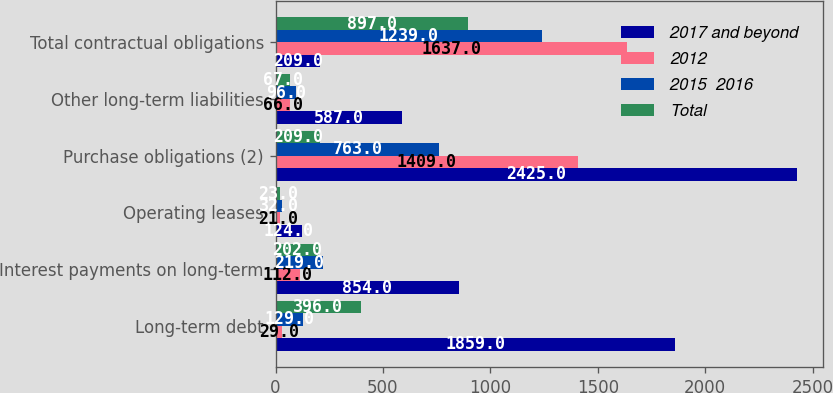Convert chart. <chart><loc_0><loc_0><loc_500><loc_500><stacked_bar_chart><ecel><fcel>Long-term debt<fcel>Interest payments on long-term<fcel>Operating leases<fcel>Purchase obligations (2)<fcel>Other long-term liabilities<fcel>Total contractual obligations<nl><fcel>2017 and beyond<fcel>1859<fcel>854<fcel>124<fcel>2425<fcel>587<fcel>209<nl><fcel>2012<fcel>29<fcel>112<fcel>21<fcel>1409<fcel>66<fcel>1637<nl><fcel>2015  2016<fcel>129<fcel>219<fcel>32<fcel>763<fcel>96<fcel>1239<nl><fcel>Total<fcel>396<fcel>202<fcel>23<fcel>209<fcel>67<fcel>897<nl></chart> 